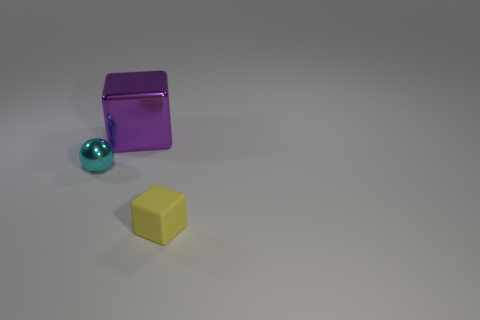What can you infer about the material of the objects from their appearances? Based on the image, the objects appear to have matte surfaces, as they do not exhibit any shiny highlights or reflections. The matte finish of the objects suggests that they are likely made of a non-glossy material like plastic, which diffuses light rather than reflecting it directly. 